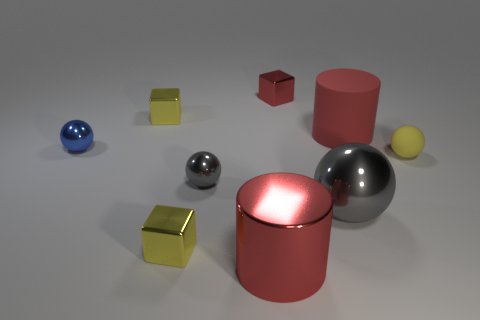How many other things are there of the same color as the big matte thing?
Offer a very short reply. 2. How many brown things are either spheres or tiny matte balls?
Your answer should be very brief. 0. What size is the blue object?
Your response must be concise. Small. How many matte things are balls or small gray cylinders?
Make the answer very short. 1. Is the number of big red shiny things less than the number of red things?
Your answer should be compact. Yes. What number of other objects are there of the same material as the big ball?
Ensure brevity in your answer.  6. What size is the metal thing that is the same shape as the large rubber object?
Your answer should be very brief. Large. Do the large red cylinder that is to the right of the large ball and the cube in front of the small gray shiny sphere have the same material?
Provide a short and direct response. No. Are there fewer yellow shiny things on the right side of the big red matte cylinder than small yellow metal objects?
Provide a short and direct response. Yes. Is there any other thing that has the same shape as the red rubber object?
Give a very brief answer. Yes. 